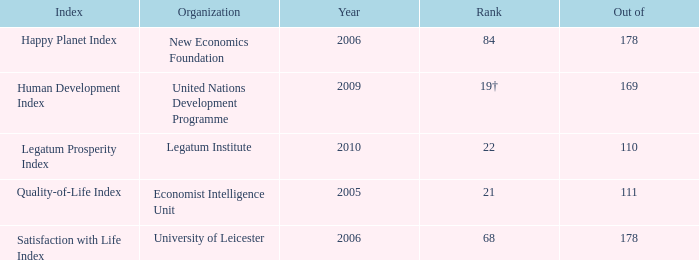What year for the legatum institute? 2010.0. 